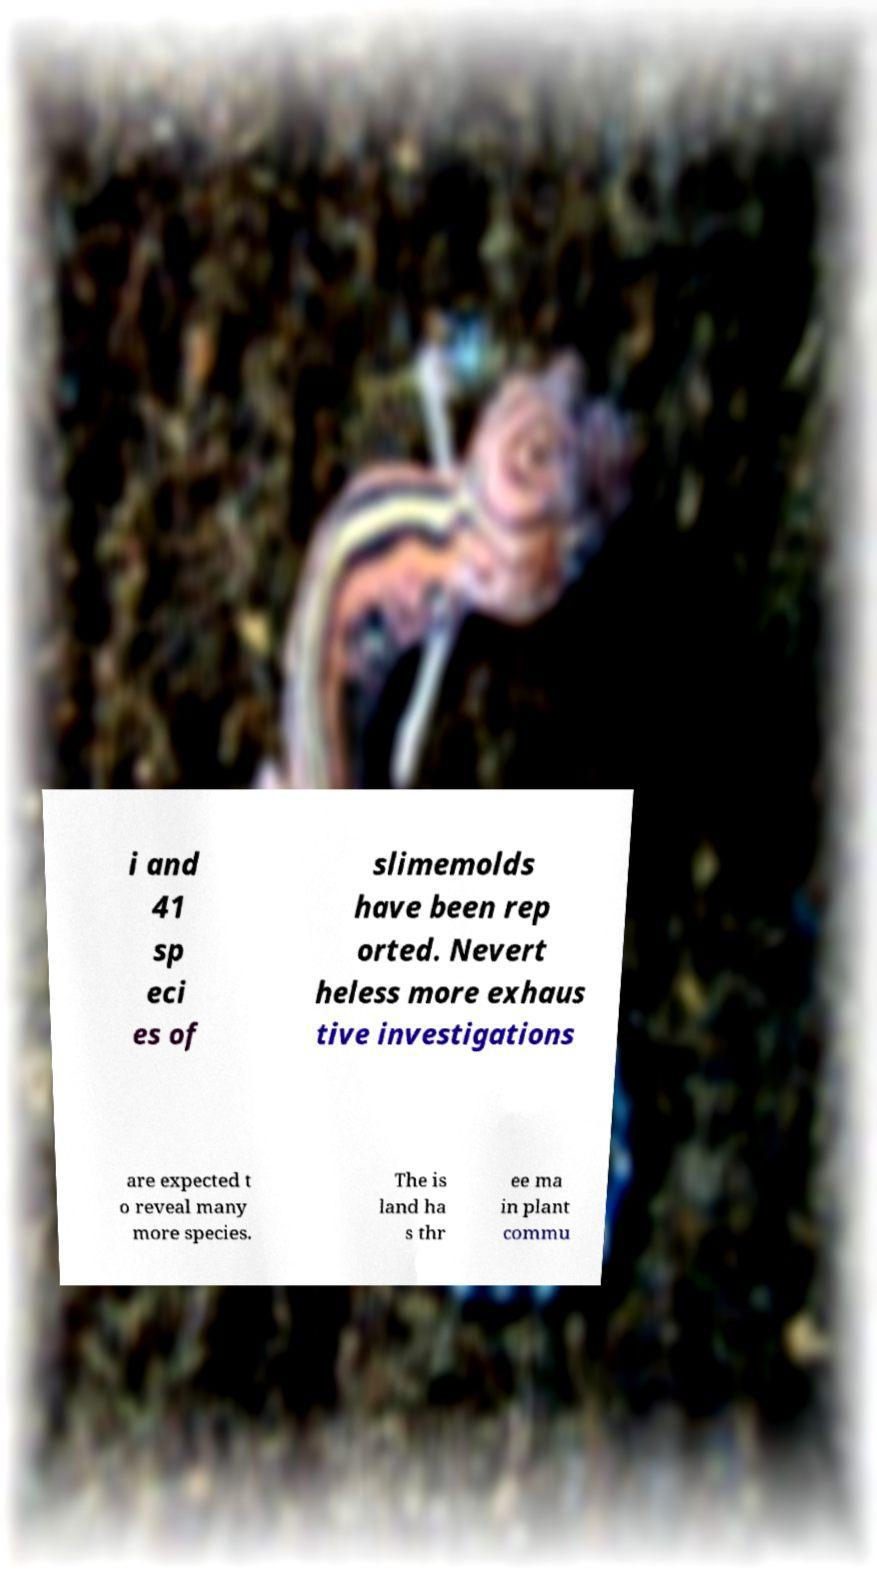Can you accurately transcribe the text from the provided image for me? i and 41 sp eci es of slimemolds have been rep orted. Nevert heless more exhaus tive investigations are expected t o reveal many more species. The is land ha s thr ee ma in plant commu 